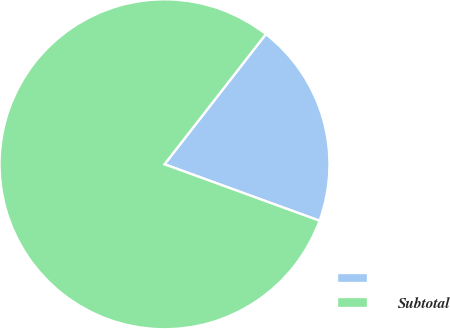Convert chart. <chart><loc_0><loc_0><loc_500><loc_500><pie_chart><ecel><fcel>Subtotal<nl><fcel>20.03%<fcel>79.97%<nl></chart> 